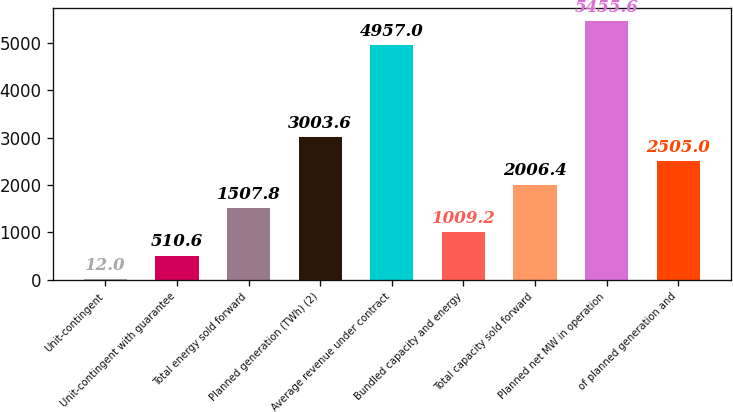<chart> <loc_0><loc_0><loc_500><loc_500><bar_chart><fcel>Unit-contingent<fcel>Unit-contingent with guarantee<fcel>Total energy sold forward<fcel>Planned generation (TWh) (2)<fcel>Average revenue under contract<fcel>Bundled capacity and energy<fcel>Total capacity sold forward<fcel>Planned net MW in operation<fcel>of planned generation and<nl><fcel>12<fcel>510.6<fcel>1507.8<fcel>3003.6<fcel>4957<fcel>1009.2<fcel>2006.4<fcel>5455.6<fcel>2505<nl></chart> 